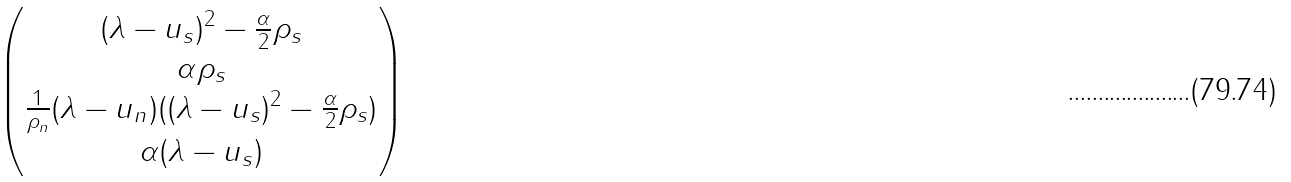Convert formula to latex. <formula><loc_0><loc_0><loc_500><loc_500>\begin{pmatrix} ( \lambda - u _ { s } ) ^ { 2 } - \frac { \alpha } { 2 } \rho _ { s } \\ \alpha \rho _ { s } \\ \frac { 1 } { \rho _ { n } } ( \lambda - u _ { n } ) ( ( \lambda - u _ { s } ) ^ { 2 } - \frac { \alpha } { 2 } \rho _ { s } ) \\ \alpha ( \lambda - u _ { s } ) \end{pmatrix}</formula> 